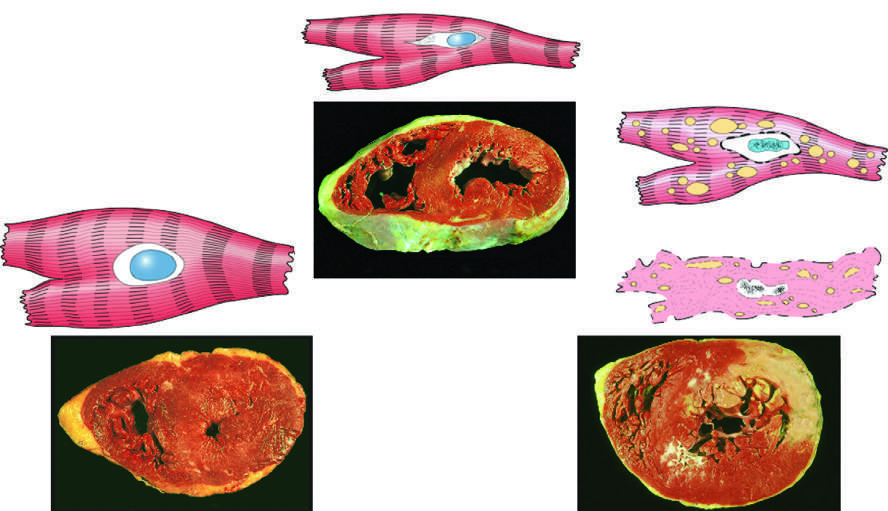what does the transmural light area in the posterolateral left ventricle represent in the specimen showing necrosis?
Answer the question using a single word or phrase. Acute myocardial infarction 